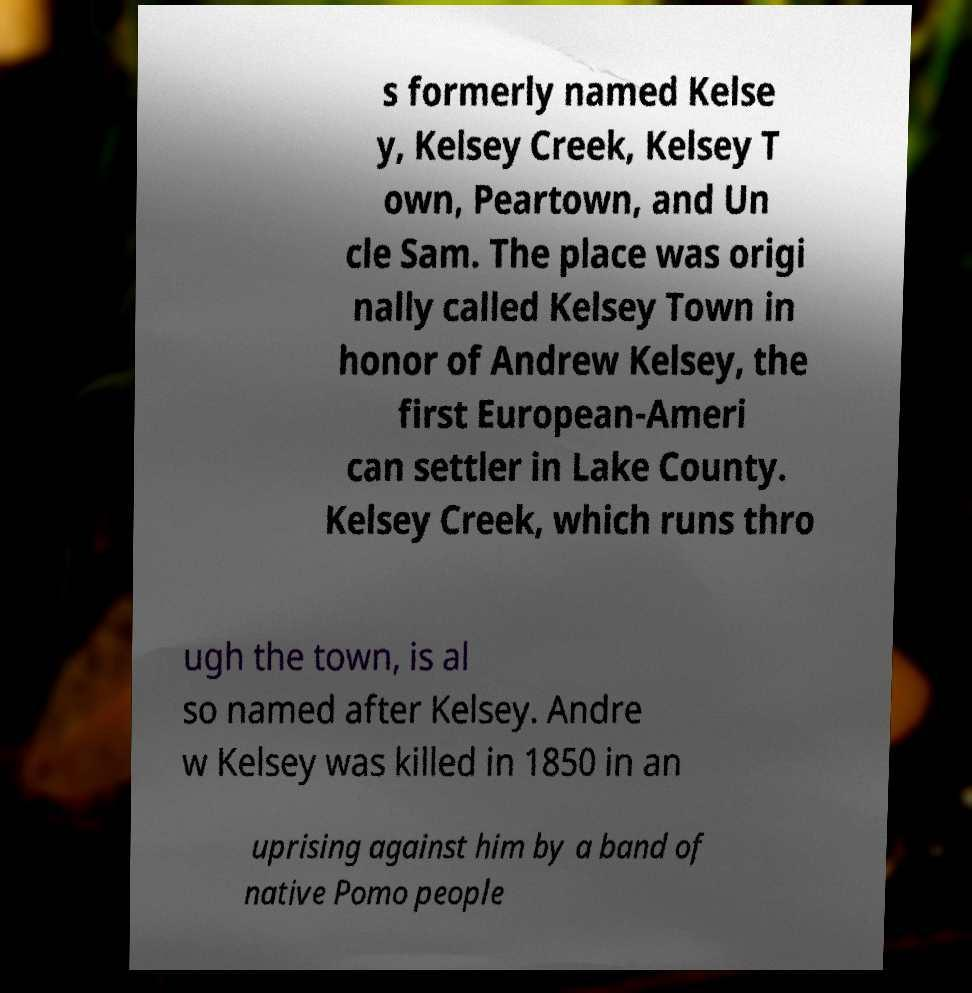For documentation purposes, I need the text within this image transcribed. Could you provide that? s formerly named Kelse y, Kelsey Creek, Kelsey T own, Peartown, and Un cle Sam. The place was origi nally called Kelsey Town in honor of Andrew Kelsey, the first European-Ameri can settler in Lake County. Kelsey Creek, which runs thro ugh the town, is al so named after Kelsey. Andre w Kelsey was killed in 1850 in an uprising against him by a band of native Pomo people 